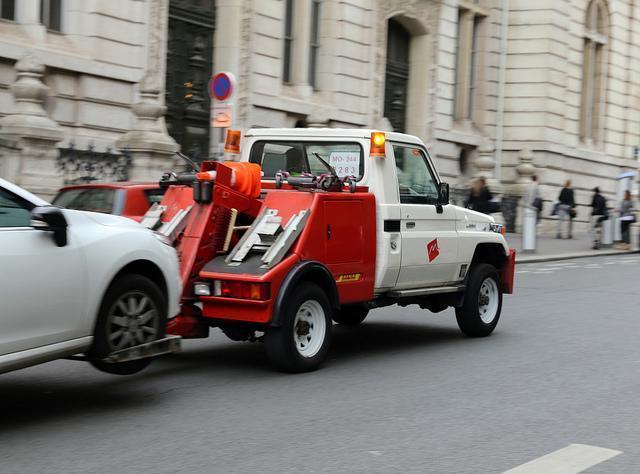How is the car on the back being propelled?
Make your selection from the four choices given to correctly answer the question.
Options: Oil, gas, coal engine, towed. Towed. What type of truck is being pictured in this image?
Make your selection and explain in format: 'Answer: answer
Rationale: rationale.'
Options: Sixteen wheeler, monster truck, chevy truck, tow truck. Answer: tow truck.
Rationale: A truck is towing another car away. 